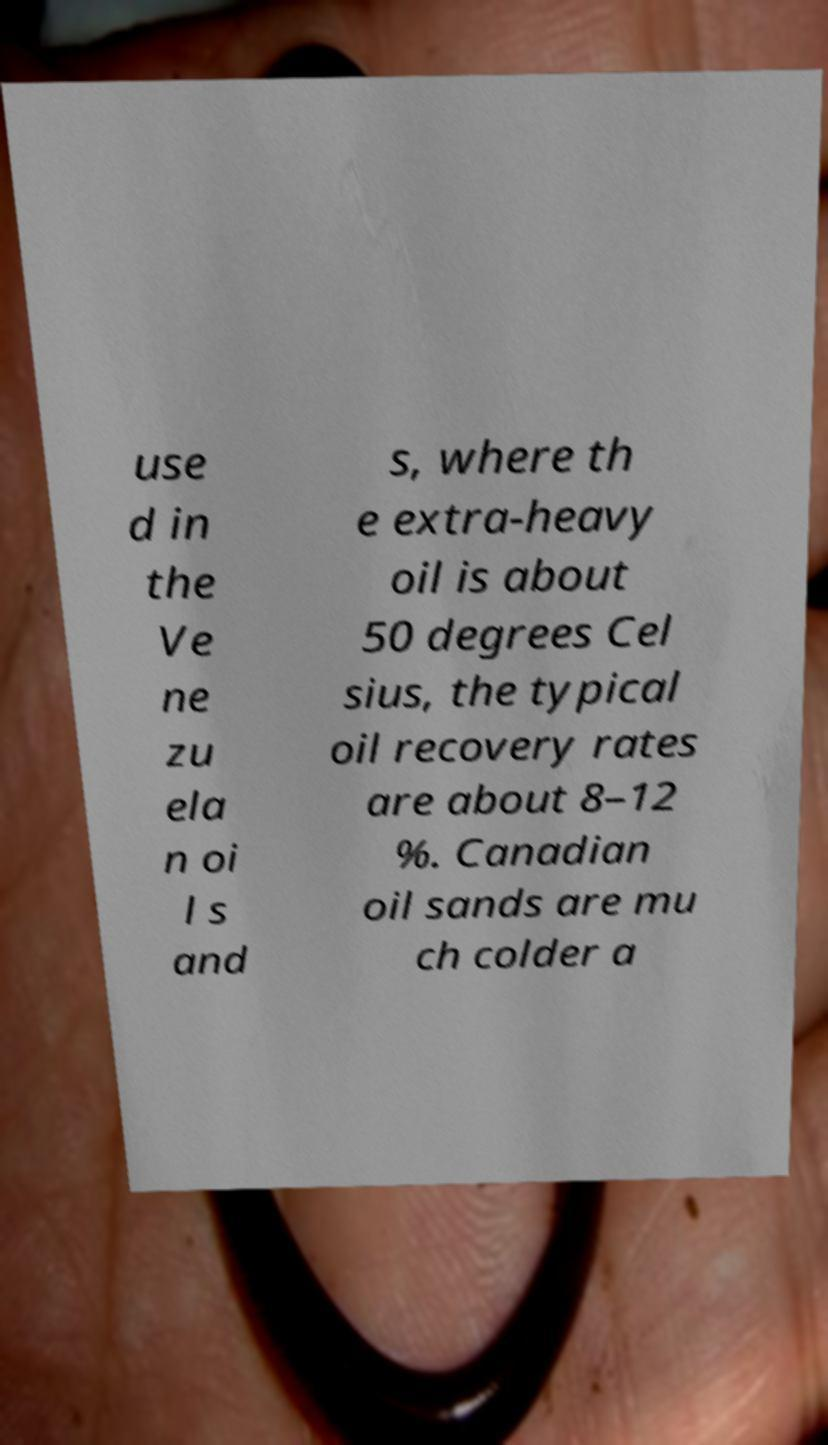Please read and relay the text visible in this image. What does it say? use d in the Ve ne zu ela n oi l s and s, where th e extra-heavy oil is about 50 degrees Cel sius, the typical oil recovery rates are about 8–12 %. Canadian oil sands are mu ch colder a 